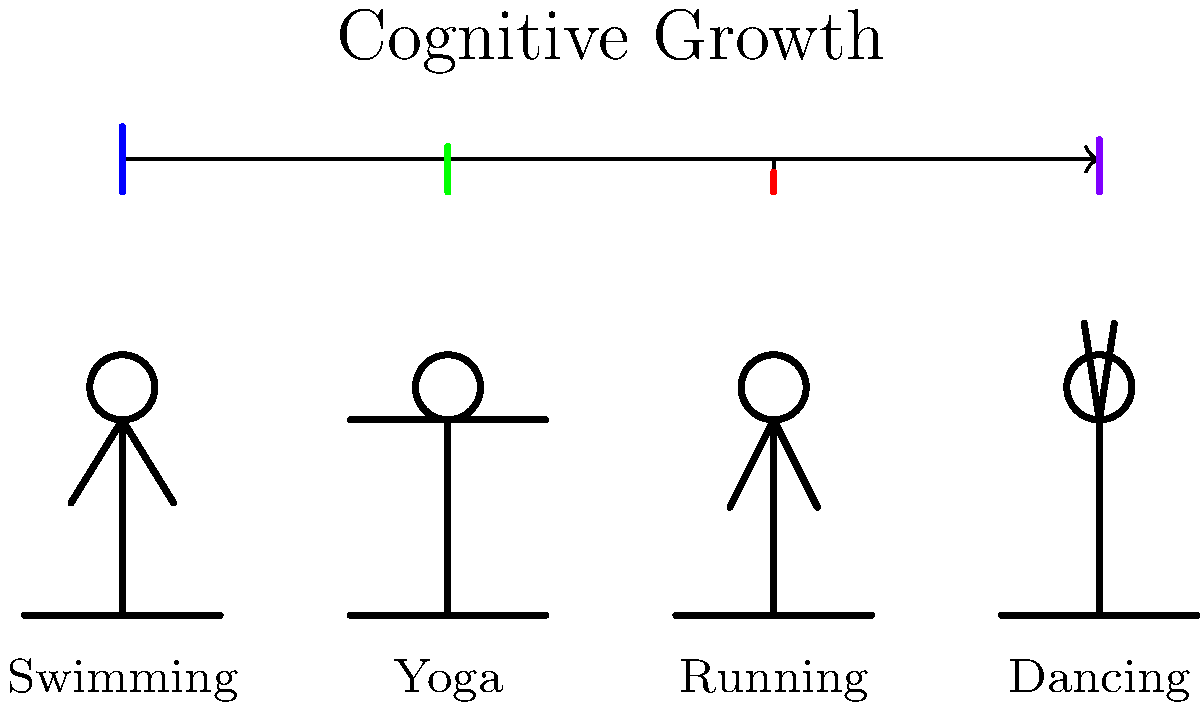Based on the stick figure illustration, which physical activity appears to have the most significant impact on a child's cognitive growth? To determine which physical activity has the most significant impact on a child's cognitive growth, we need to analyze the diagram:

1. The horizontal arrow at the top represents cognitive growth.
2. Each stick figure represents a different physical activity: swimming, yoga, running, and dancing.
3. The vertical lines above each activity indicate the level of cognitive growth associated with that activity.

Comparing the heights of the vertical lines:
1. Swimming (blue line): Reaches the highest point
2. Dancing (purple line): Second highest
3. Yoga (green line): Third highest
4. Running (red line): Lowest point

The height of each line correlates with the activity's impact on cognitive growth. The taller the line, the greater the impact.

Therefore, based on this illustration, swimming appears to have the most significant impact on a child's cognitive growth, as it has the tallest vertical line reaching towards the "Cognitive Growth" arrow.
Answer: Swimming 